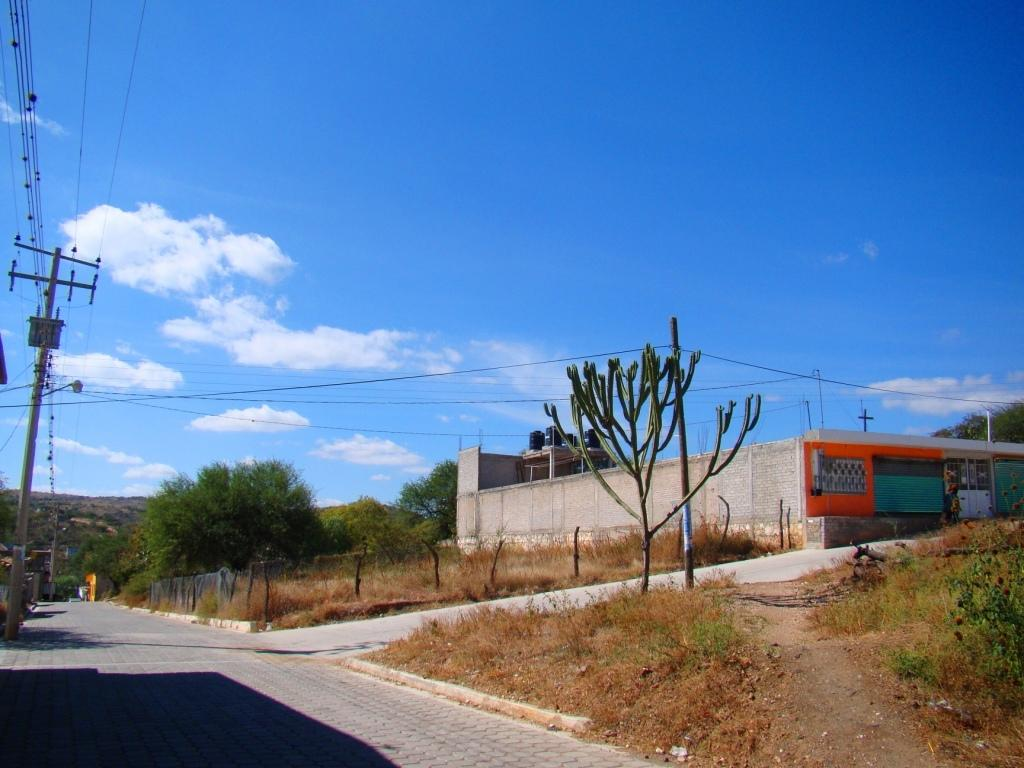What is the main feature of the image? There is a road in the image. What type of vegetation can be seen in the image? There are plants, grass, and trees in the image. What structures are present in the image? There is a fence, poles, wires, and a building in the image. What is the background of the image? In the background of the image, there is a hill and the sky is visible. What can be seen in the sky? There are clouds in the sky. How many boats are visible in the image? There are no boats present in the image. What type of cattle can be seen grazing on the hill in the background? There is no cattle present in the image; only a hill and the sky are visible in the background. 